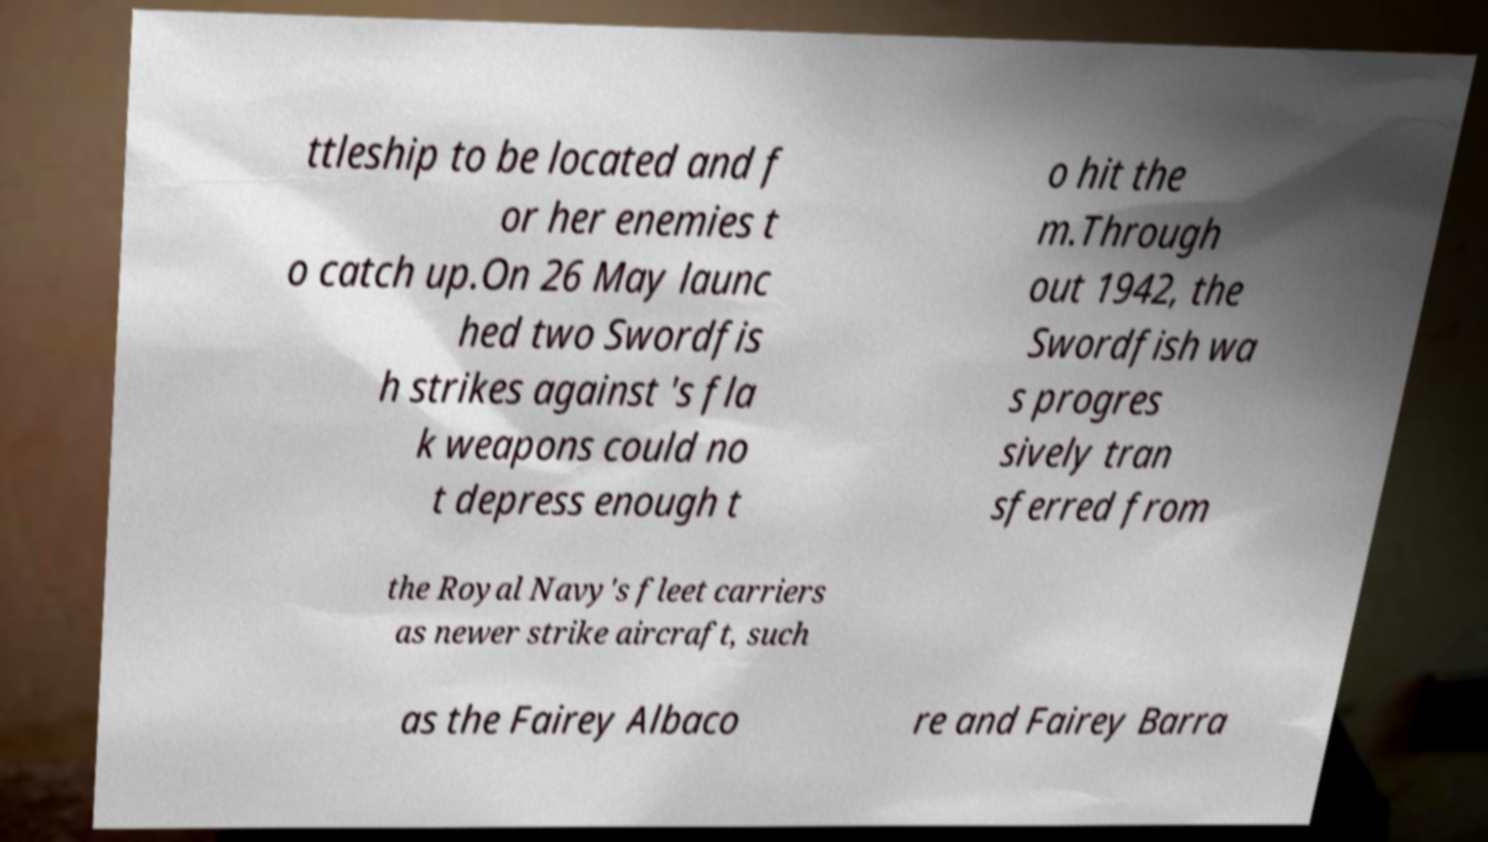Please identify and transcribe the text found in this image. ttleship to be located and f or her enemies t o catch up.On 26 May launc hed two Swordfis h strikes against 's fla k weapons could no t depress enough t o hit the m.Through out 1942, the Swordfish wa s progres sively tran sferred from the Royal Navy's fleet carriers as newer strike aircraft, such as the Fairey Albaco re and Fairey Barra 